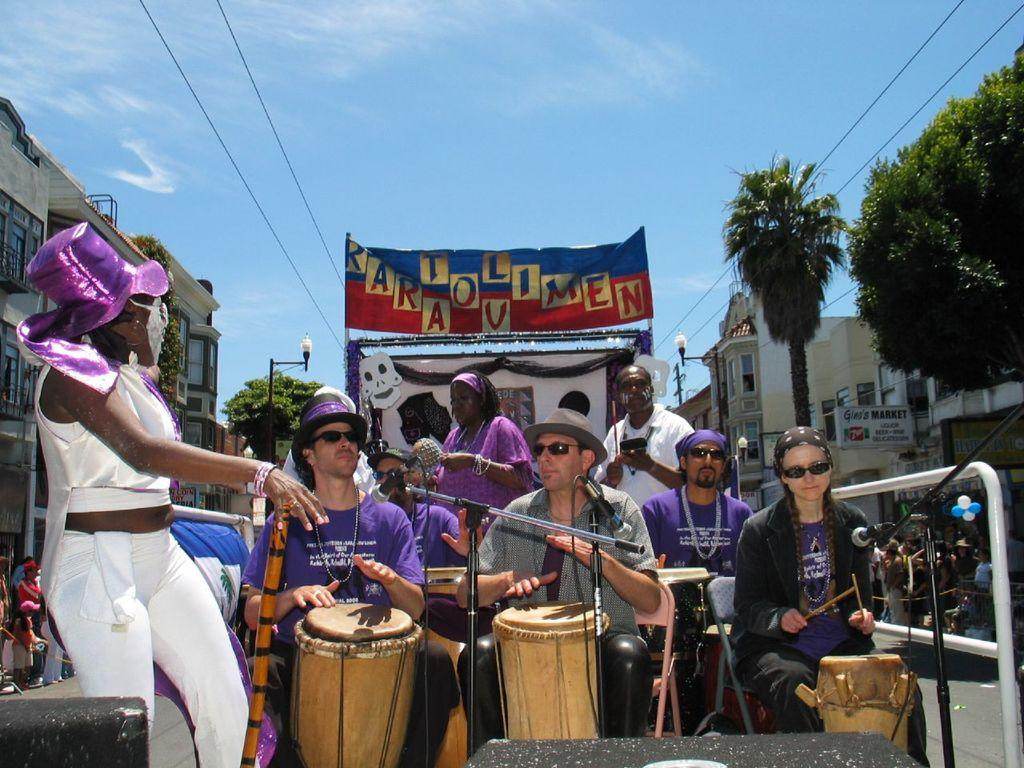What activity are the five people in the image engaged in? The five people in the image are playing drums. Can you describe the background of the image? There are two guys standing in the background of the image, and there is a poster named "rara tou limen." How many people are playing drums in the image? Five people are playing drums in the image. What type of cord is being used by the people playing drums in the image? There is no mention of a cord being used by the people playing drums in the image. 